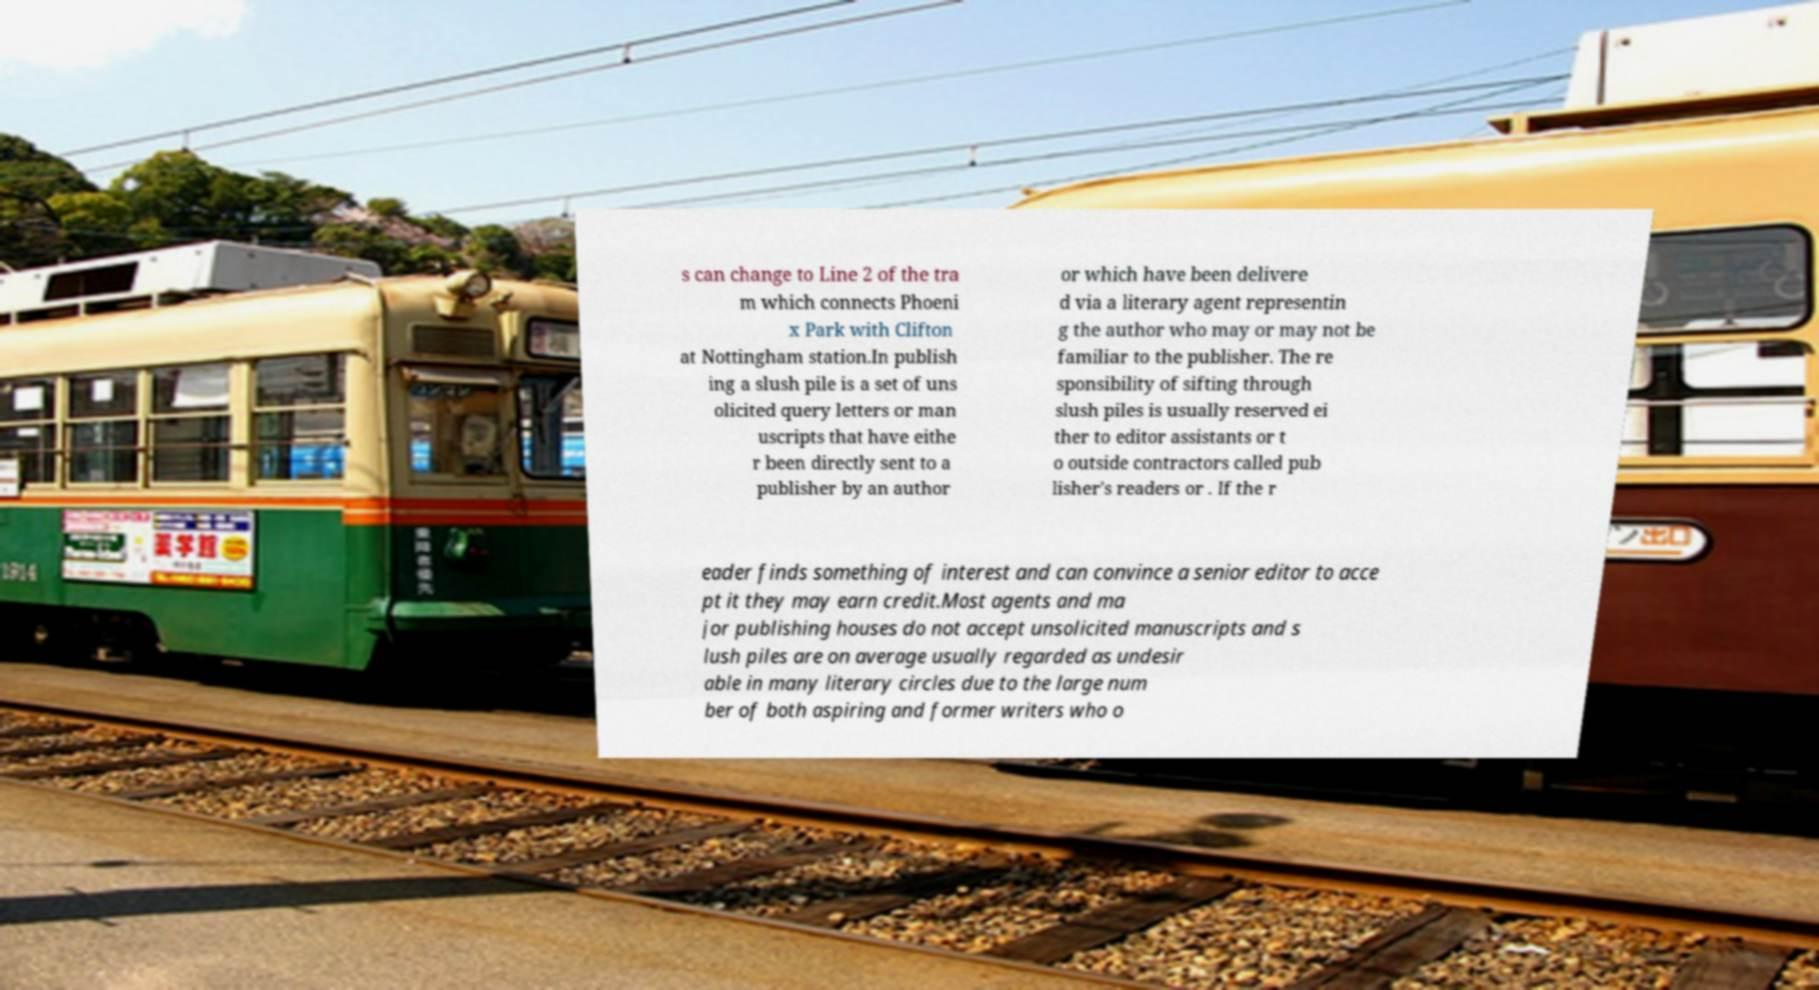For documentation purposes, I need the text within this image transcribed. Could you provide that? s can change to Line 2 of the tra m which connects Phoeni x Park with Clifton at Nottingham station.In publish ing a slush pile is a set of uns olicited query letters or man uscripts that have eithe r been directly sent to a publisher by an author or which have been delivere d via a literary agent representin g the author who may or may not be familiar to the publisher. The re sponsibility of sifting through slush piles is usually reserved ei ther to editor assistants or t o outside contractors called pub lisher's readers or . If the r eader finds something of interest and can convince a senior editor to acce pt it they may earn credit.Most agents and ma jor publishing houses do not accept unsolicited manuscripts and s lush piles are on average usually regarded as undesir able in many literary circles due to the large num ber of both aspiring and former writers who o 